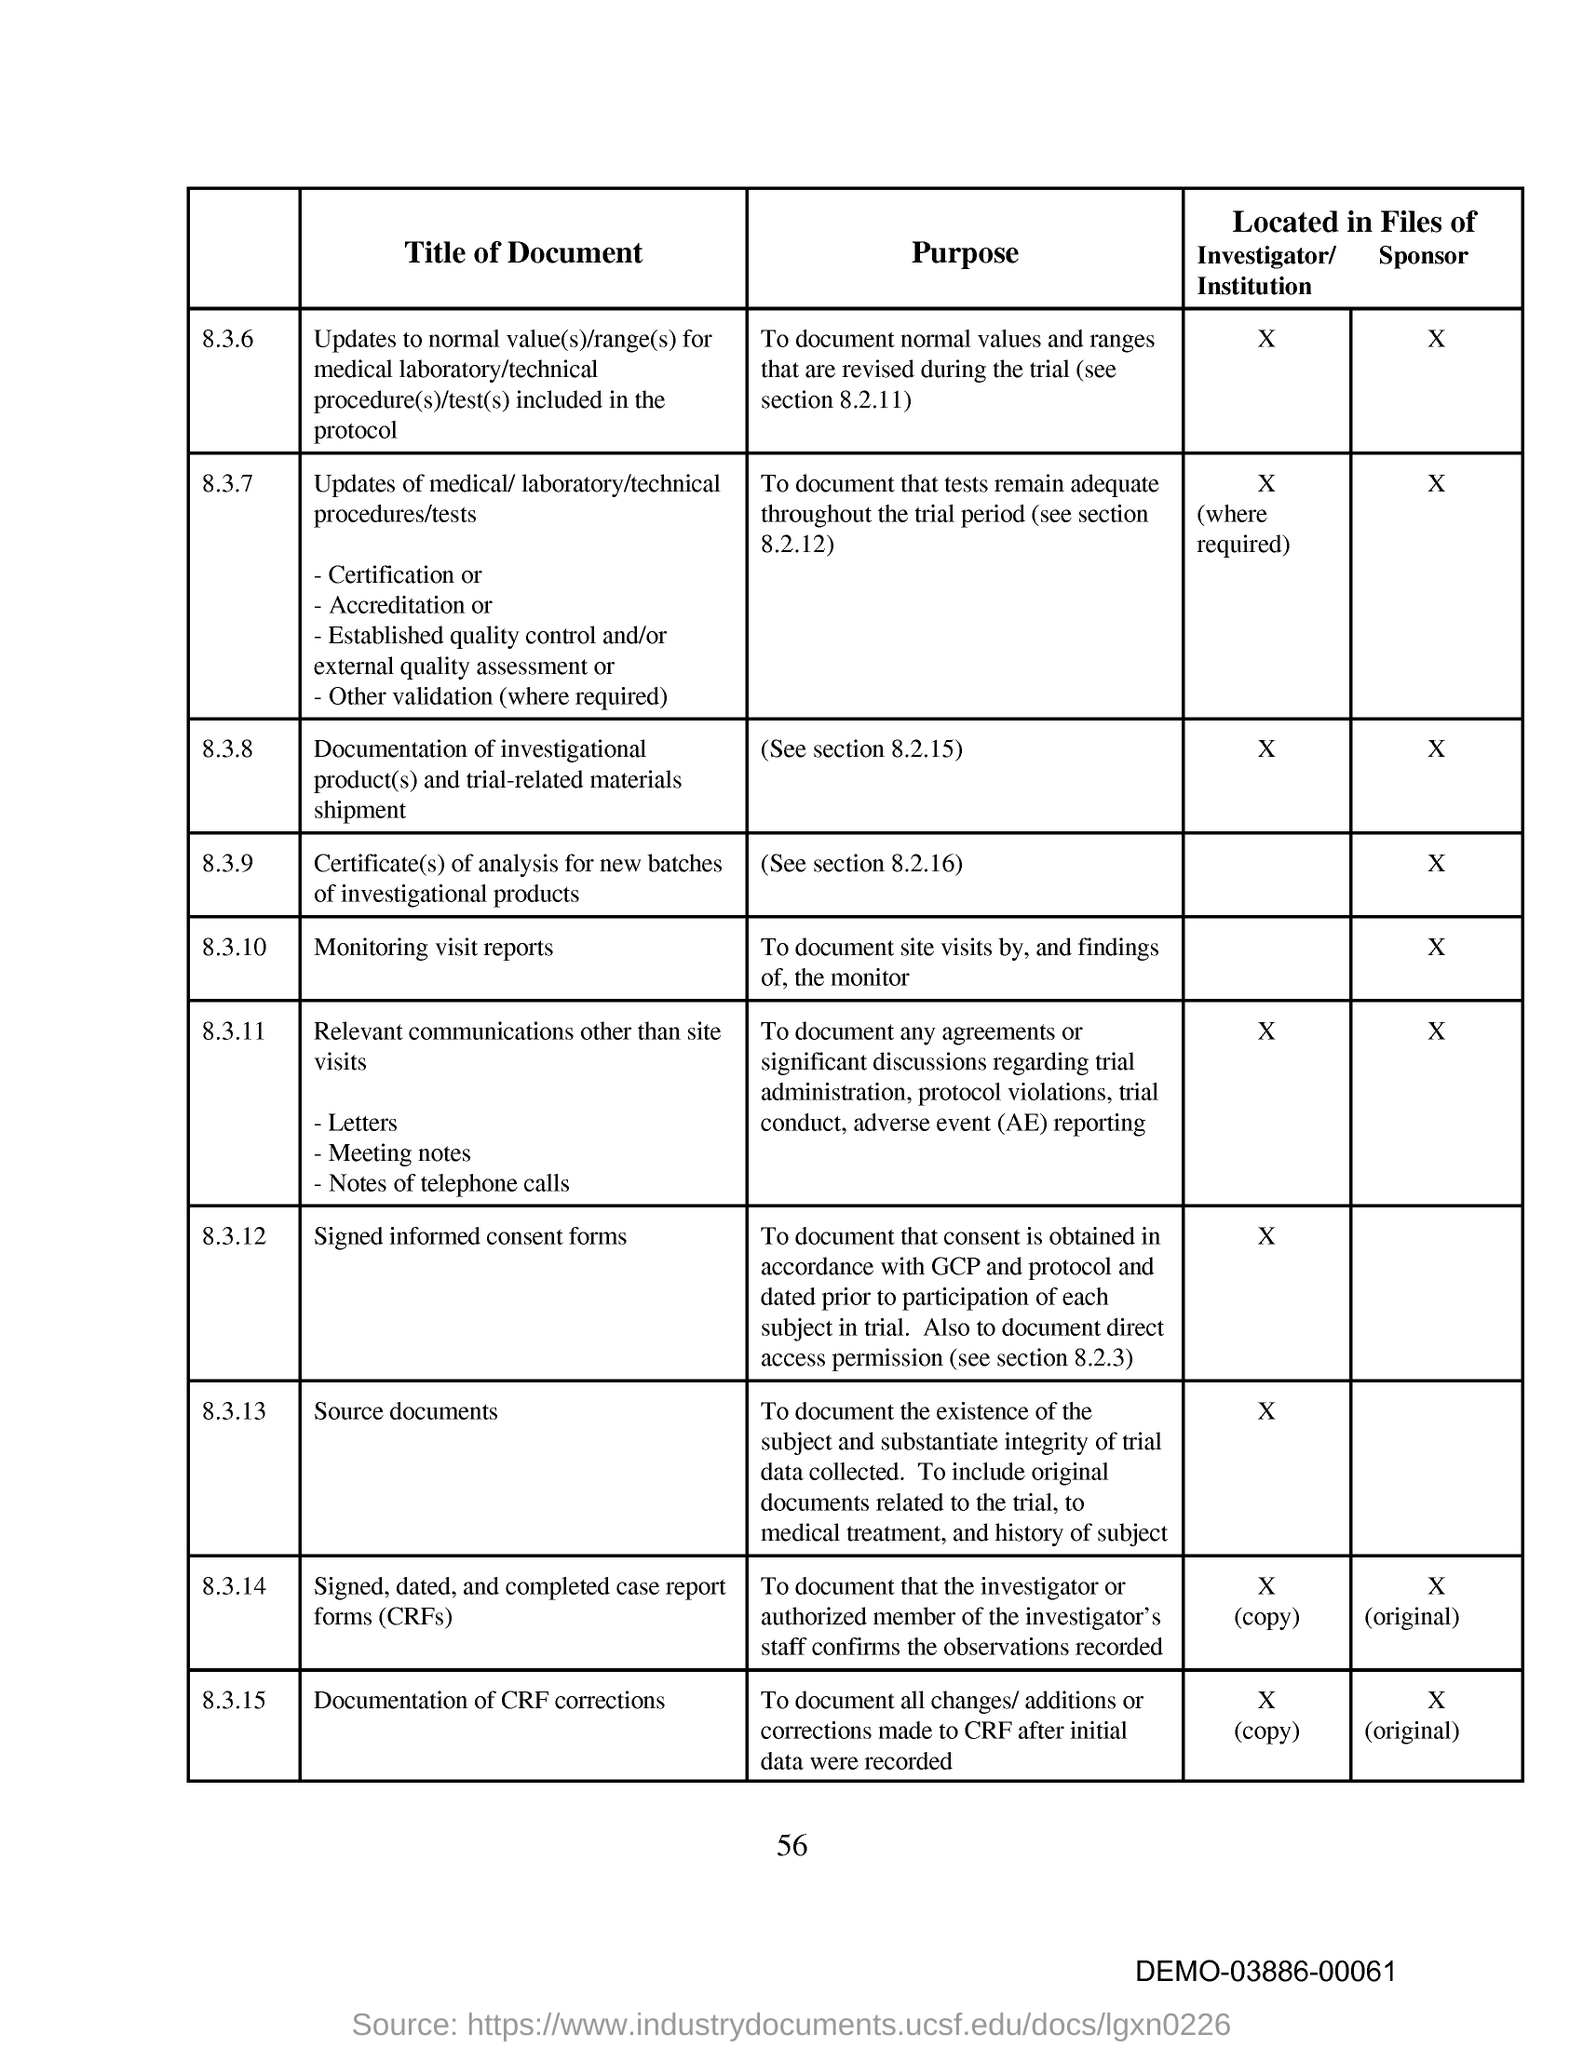What is the purpose of section 8.3.10.?
Give a very brief answer. To document site visits by, and findings of, the monitor. What is the code at the bottom right corner of the page?
Provide a short and direct response. DEMO-03886-00061. What is the page number on this document?
Ensure brevity in your answer.  56. 